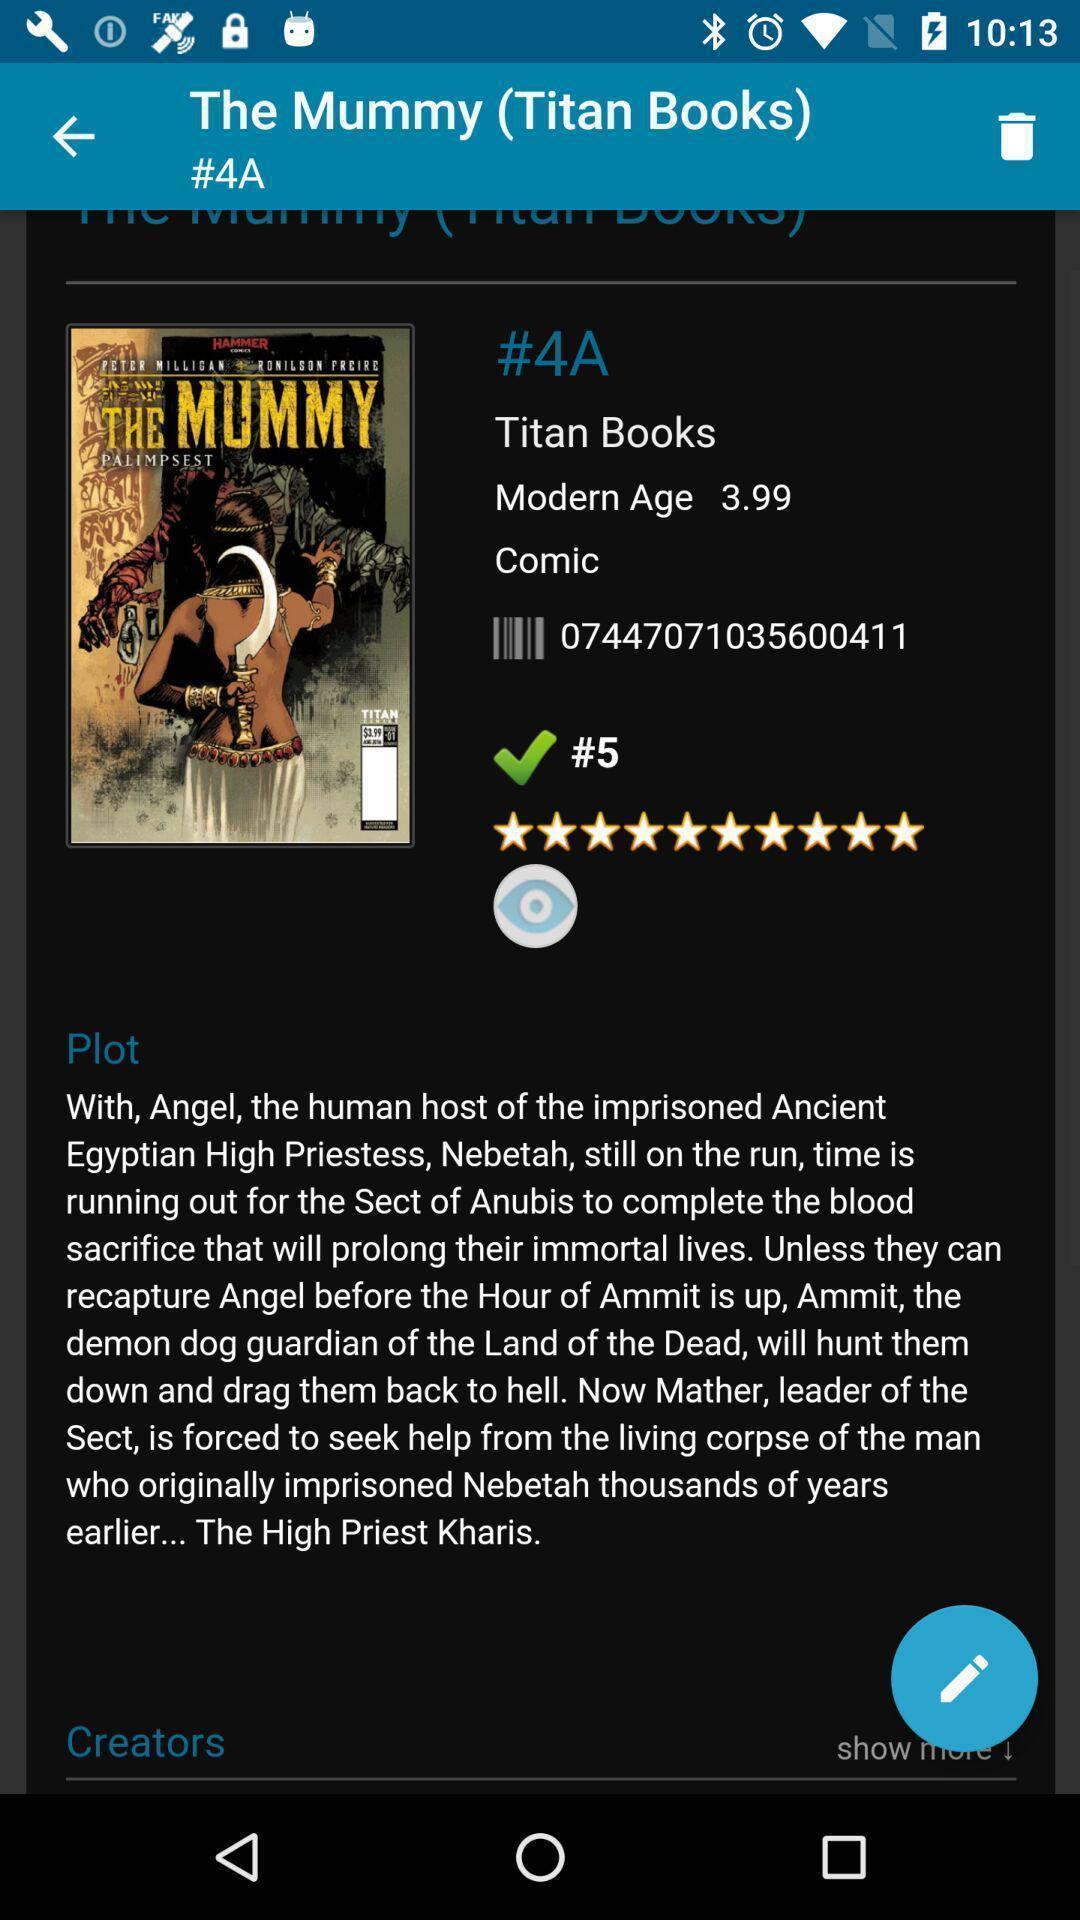Provide a description of this screenshot. Window displaying comics book page. 